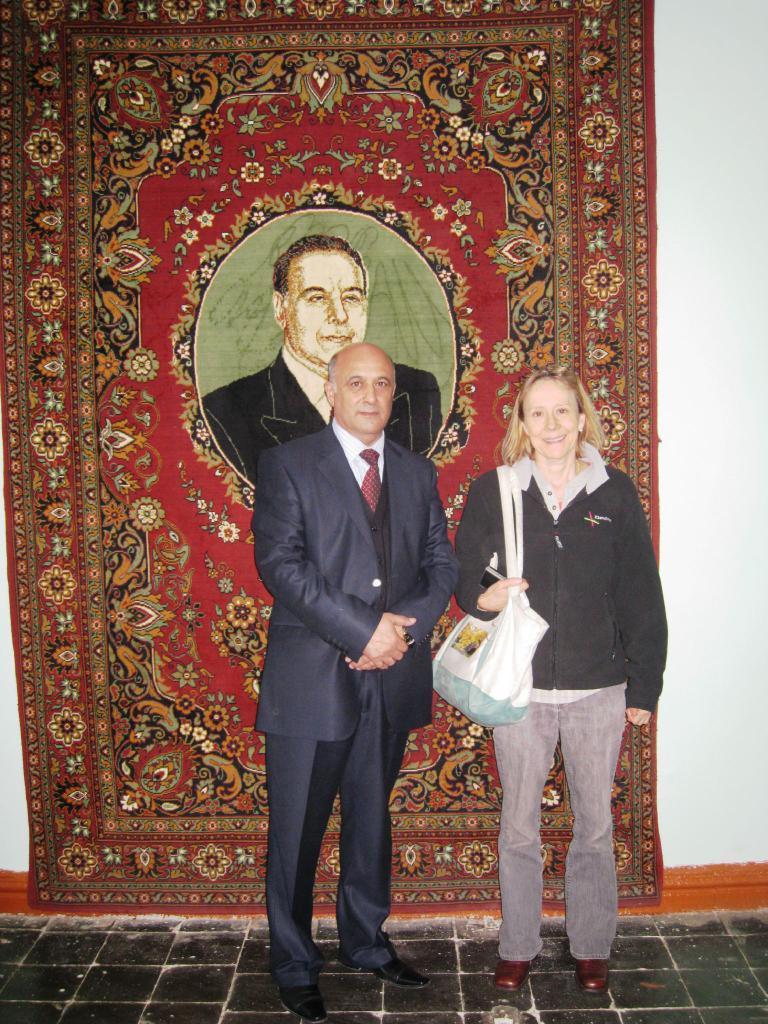Describe this image in one or two sentences. In the foreground of this image, there is a woman standing and wearing bags and also a man standing on the floor. In the background, there is a carpet and the wall. 